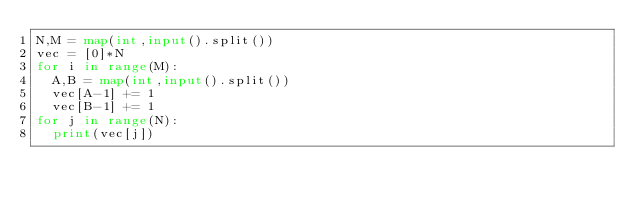<code> <loc_0><loc_0><loc_500><loc_500><_Python_>N,M = map(int,input().split())
vec = [0]*N
for i in range(M):
  A,B = map(int,input().split())
  vec[A-1] += 1
  vec[B-1] += 1
for j in range(N):
  print(vec[j])</code> 